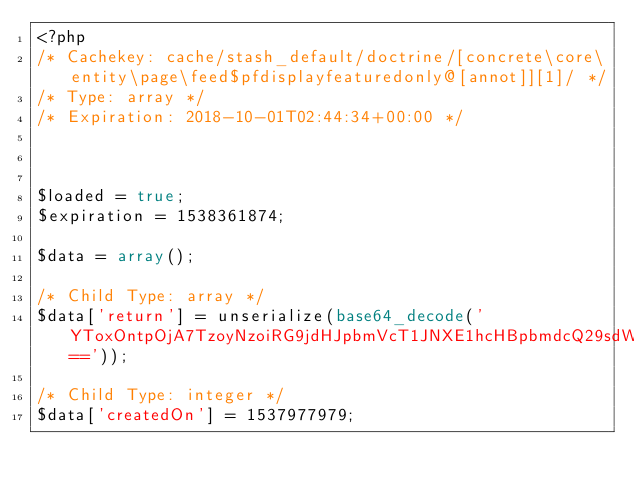<code> <loc_0><loc_0><loc_500><loc_500><_PHP_><?php 
/* Cachekey: cache/stash_default/doctrine/[concrete\core\entity\page\feed$pfdisplayfeaturedonly@[annot]][1]/ */
/* Type: array */
/* Expiration: 2018-10-01T02:44:34+00:00 */



$loaded = true;
$expiration = 1538361874;

$data = array();

/* Child Type: array */
$data['return'] = unserialize(base64_decode('YToxOntpOjA7TzoyNzoiRG9jdHJpbmVcT1JNXE1hcHBpbmdcQ29sdW1uIjo5OntzOjQ6Im5hbWUiO047czo0OiJ0eXBlIjtzOjc6ImJvb2xlYW4iO3M6NjoibGVuZ3RoIjtOO3M6OToicHJlY2lzaW9uIjtpOjA7czo1OiJzY2FsZSI7aTowO3M6NjoidW5pcXVlIjtiOjA7czo4OiJudWxsYWJsZSI7YjowO3M6Nzoib3B0aW9ucyI7YTowOnt9czoxNjoiY29sdW1uRGVmaW5pdGlvbiI7Tjt9fQ=='));

/* Child Type: integer */
$data['createdOn'] = 1537977979;
</code> 